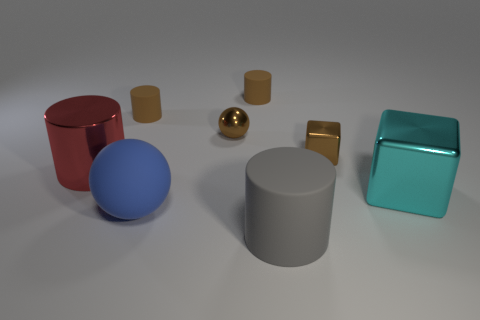How many other things are there of the same size as the cyan metallic thing?
Ensure brevity in your answer.  3. What is the shape of the brown metallic thing that is left of the big cylinder that is in front of the metallic object that is left of the blue matte object?
Make the answer very short. Sphere. What number of red objects are either blocks or small blocks?
Your answer should be compact. 0. There is a cylinder that is in front of the large cyan cube; how many tiny metal balls are on the left side of it?
Ensure brevity in your answer.  1. Is there any other thing that is the same color as the big sphere?
Keep it short and to the point. No. There is a blue thing that is the same material as the gray cylinder; what is its shape?
Make the answer very short. Sphere. Do the tiny sphere and the big metallic cylinder have the same color?
Your response must be concise. No. Are the ball in front of the brown metal cube and the small thing on the right side of the gray cylinder made of the same material?
Offer a terse response. No. What number of objects are large red rubber blocks or brown things that are left of the large gray thing?
Offer a terse response. 3. Is there any other thing that is the same material as the brown cube?
Provide a succinct answer. Yes. 